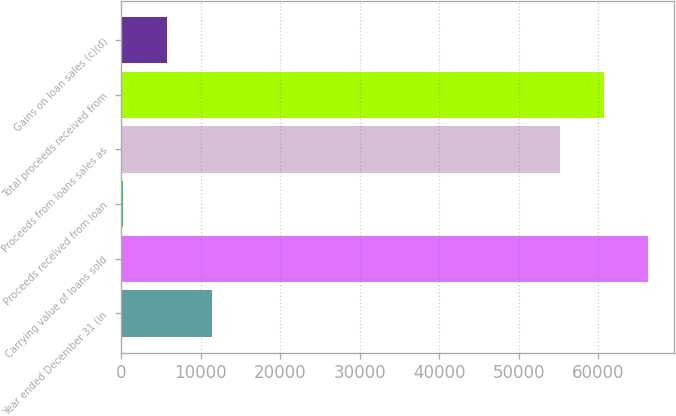<chart> <loc_0><loc_0><loc_500><loc_500><bar_chart><fcel>Year ended December 31 (in<fcel>Carrying value of loans sold<fcel>Proceeds received from loan<fcel>Proceeds from loans sales as<fcel>Total proceeds received from<fcel>Gains on loan sales (c)(d)<nl><fcel>11368.4<fcel>66225.4<fcel>260<fcel>55117<fcel>60671.2<fcel>5814.2<nl></chart> 